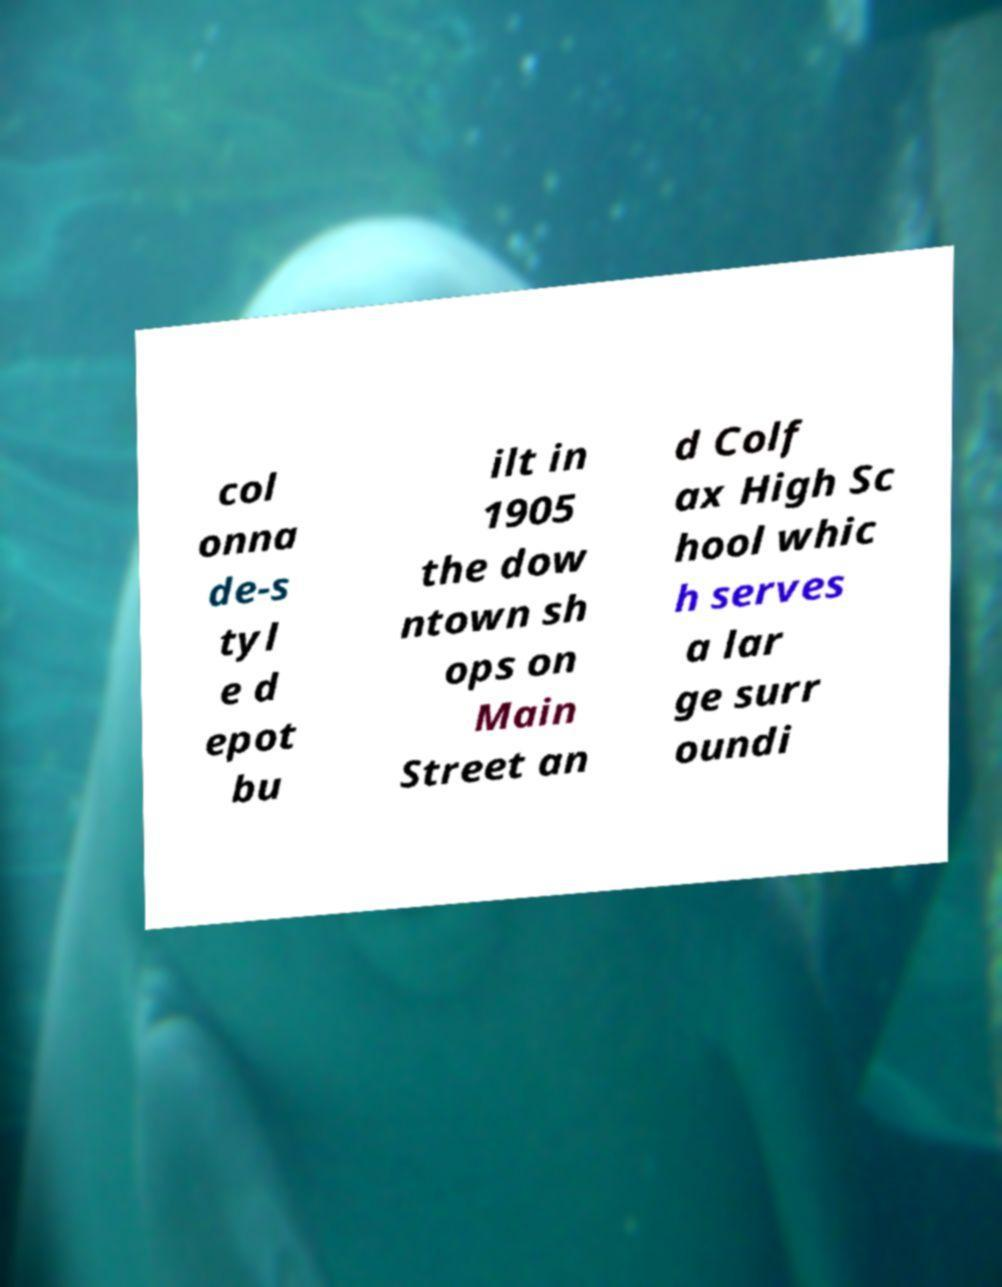Can you read and provide the text displayed in the image?This photo seems to have some interesting text. Can you extract and type it out for me? col onna de-s tyl e d epot bu ilt in 1905 the dow ntown sh ops on Main Street an d Colf ax High Sc hool whic h serves a lar ge surr oundi 